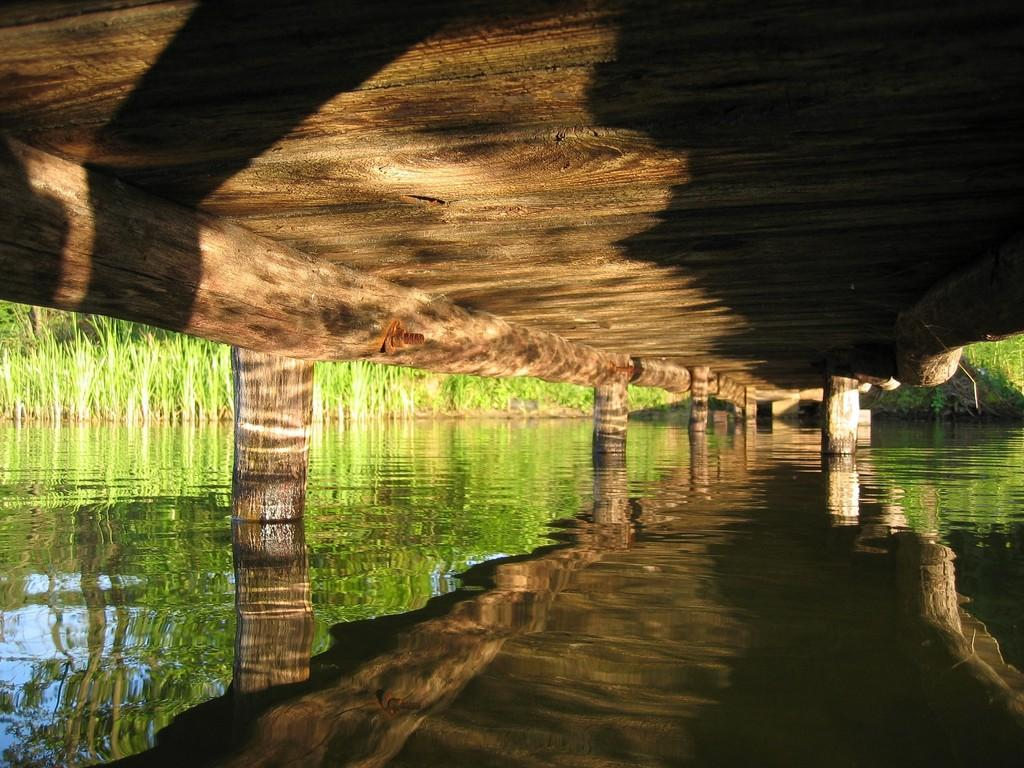What is the primary element visible in the image? There is water in the image. What structures can be seen in the center of the image? There are pillars in the center of the image. What celestial bodies are visible in the background of the image? There are planets visible in the background of the image. What effect is visible on the water's surface? There is a reflection on the water. What type of clouds can be seen in the image? There are no clouds visible in the image; it features water, pillars, and planets. Is there a snake visible in the image? There is no snake present in the image. 